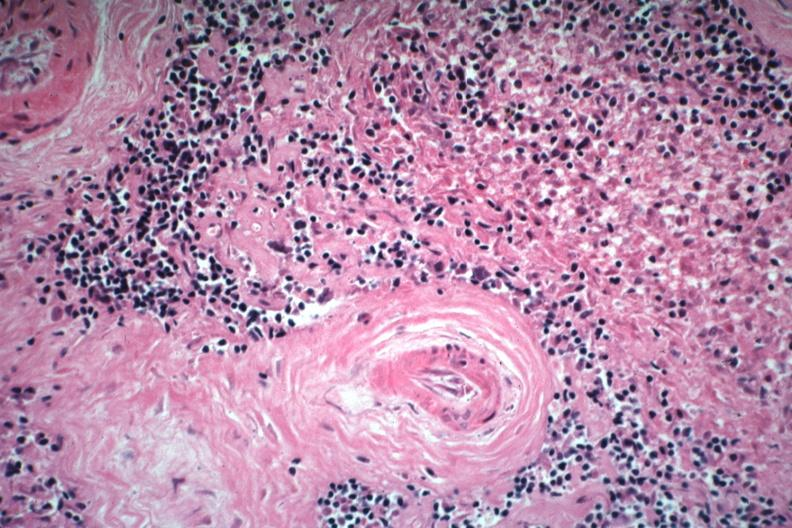s lupus erythematosus basophilic bodies and periarterial fibrosis present?
Answer the question using a single word or phrase. Yes 